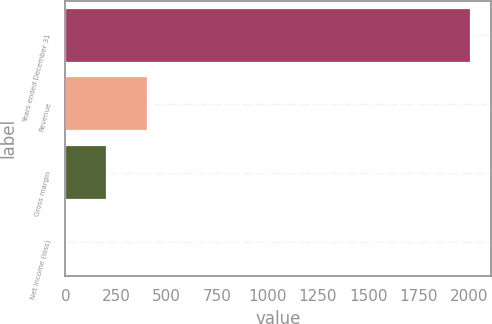Convert chart. <chart><loc_0><loc_0><loc_500><loc_500><bar_chart><fcel>Years ended December 31<fcel>Revenue<fcel>Gross margin<fcel>Net income (loss)<nl><fcel>2010<fcel>407.6<fcel>207.3<fcel>7<nl></chart> 